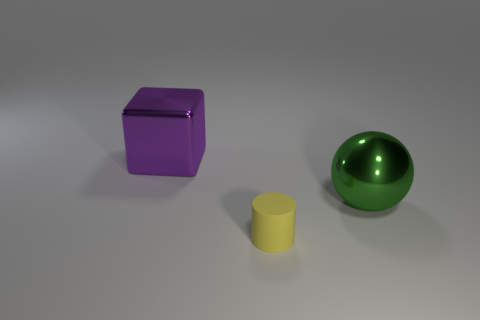Add 1 big shiny cylinders. How many objects exist? 4 Subtract all blocks. How many objects are left? 2 Subtract all brown matte cubes. Subtract all shiny spheres. How many objects are left? 2 Add 1 green balls. How many green balls are left? 2 Add 1 big gray things. How many big gray things exist? 1 Subtract 0 purple cylinders. How many objects are left? 3 